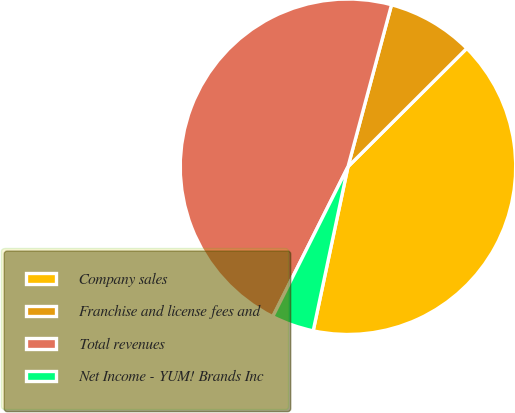Convert chart to OTSL. <chart><loc_0><loc_0><loc_500><loc_500><pie_chart><fcel>Company sales<fcel>Franchise and license fees and<fcel>Total revenues<fcel>Net Income - YUM! Brands Inc<nl><fcel>40.8%<fcel>8.35%<fcel>46.78%<fcel>4.08%<nl></chart> 